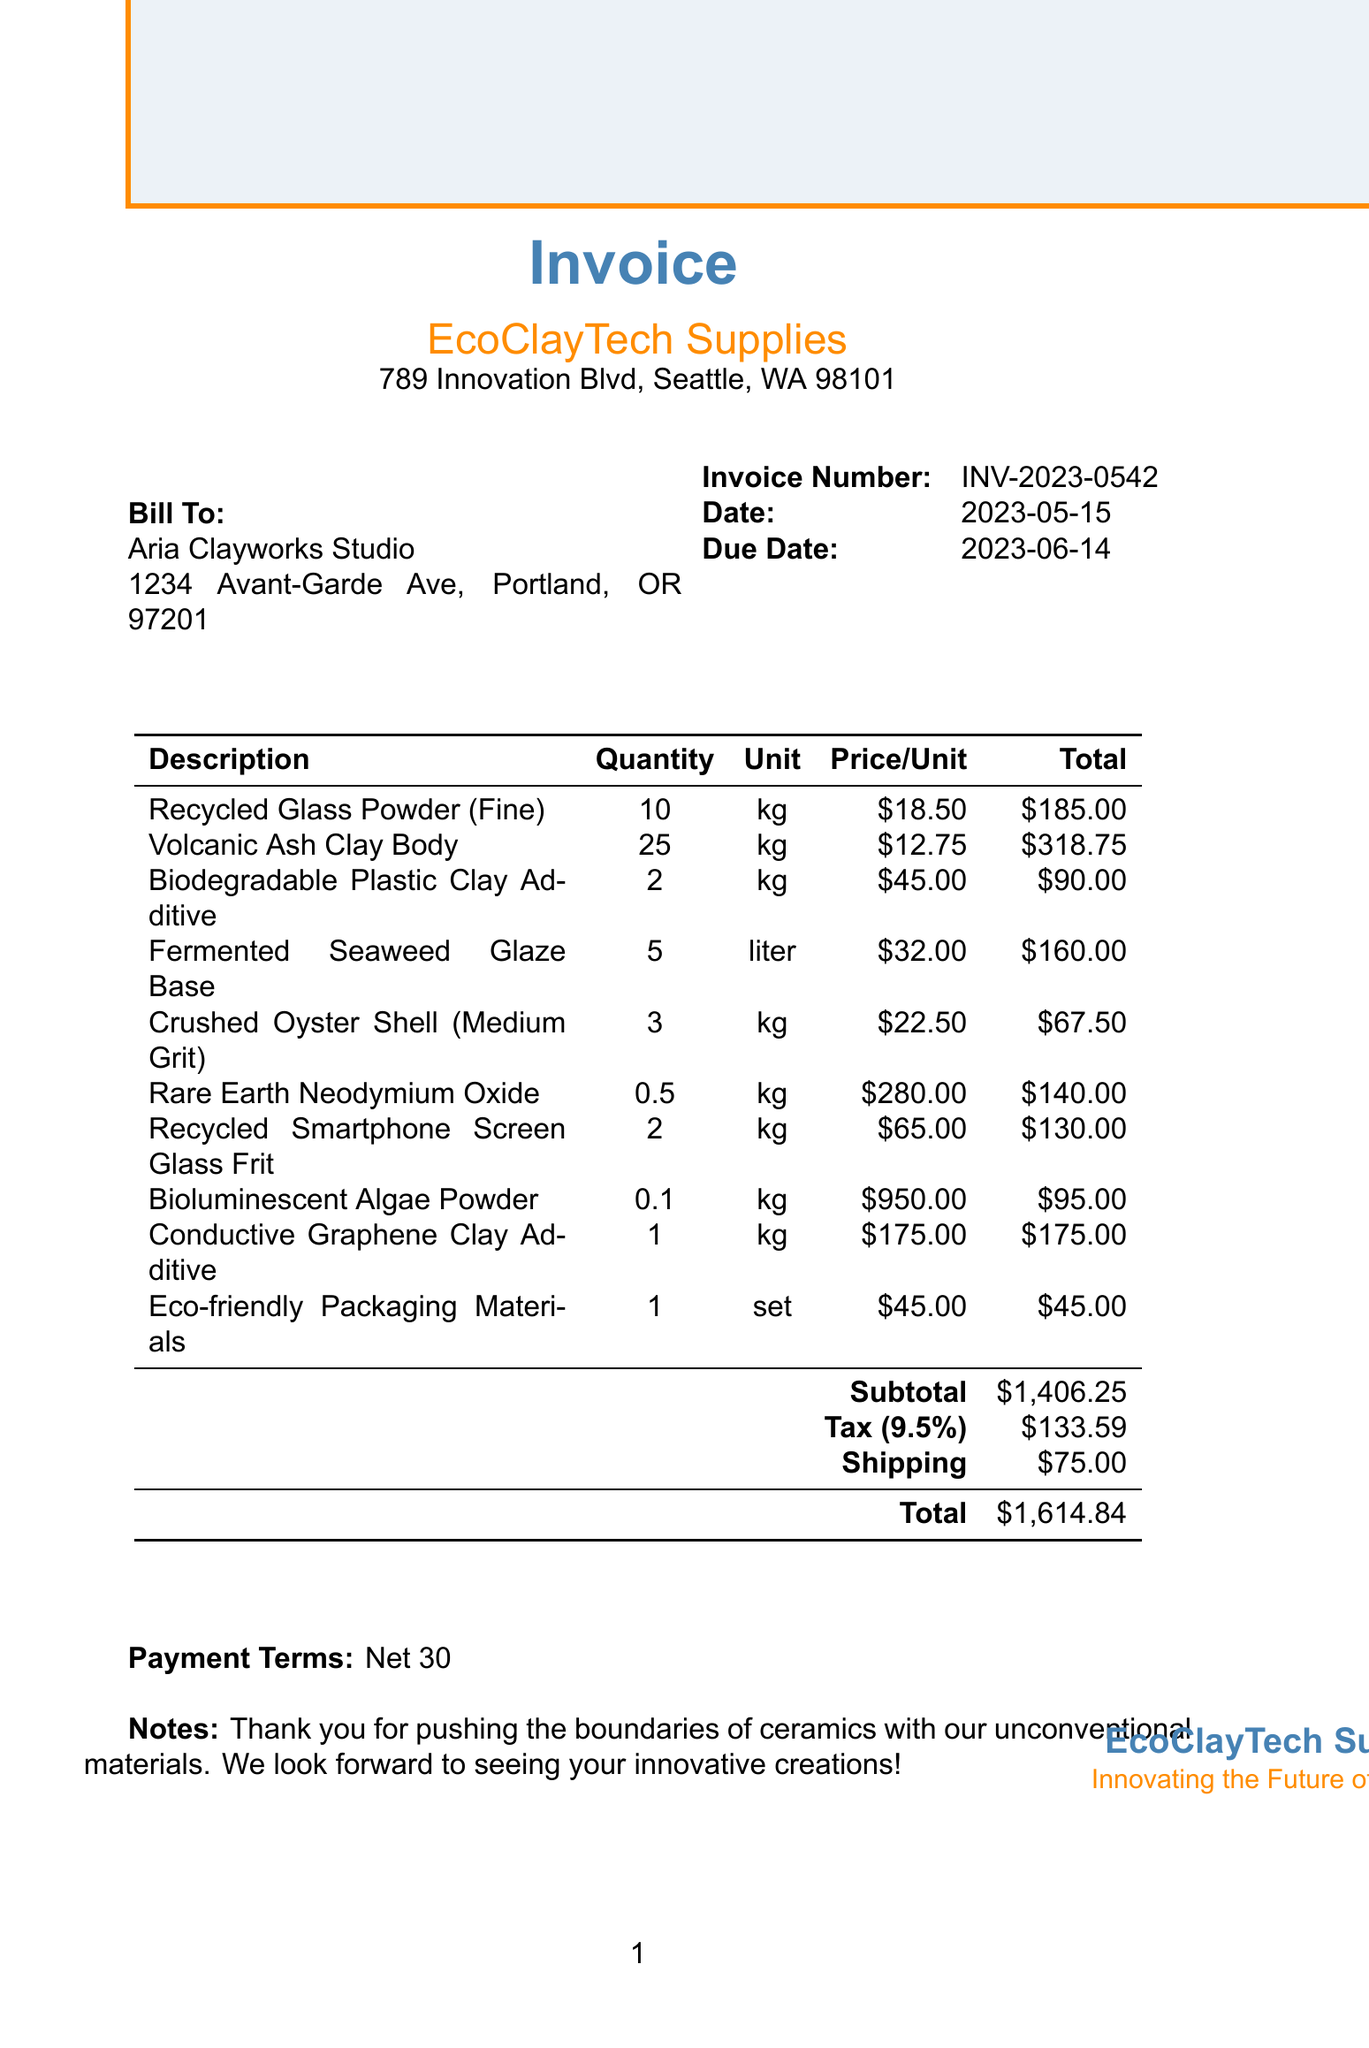What is the invoice number? The invoice number is a unique identifier for the invoice and can be found in the document.
Answer: INV-2023-0542 Who is the seller? The seller's name and address are indicated in the heading of the invoice.
Answer: EcoClayTech Supplies What is the total amount due? The total amount due is clearly stated at the bottom of the invoice after all calculations.
Answer: $1614.84 What is the tax rate? The tax rate is mentioned in the invoice and is applied to the subtotal.
Answer: 9.5% How many kilograms of Fermented Seaweed Glaze Base were purchased? The quantity for each item is specified in the itemized list of the invoice.
Answer: 5 What is the subtotal before tax and shipping? The subtotal is calculated before tax and shipping costs are added and is specified in the document.
Answer: $1,406.25 When is the due date for payment? The due date is provided with the invoice details for clarity on the payment timeline.
Answer: 2023-06-14 What is the payment term specified in the invoice? The payment terms are outlined to indicate when the payment will be expected.
Answer: Net 30 What type of material is the Bioluminescent Algae Powder categorized under? The description indicates the nature of the material being purchased.
Answer: Unconventional ingredient 